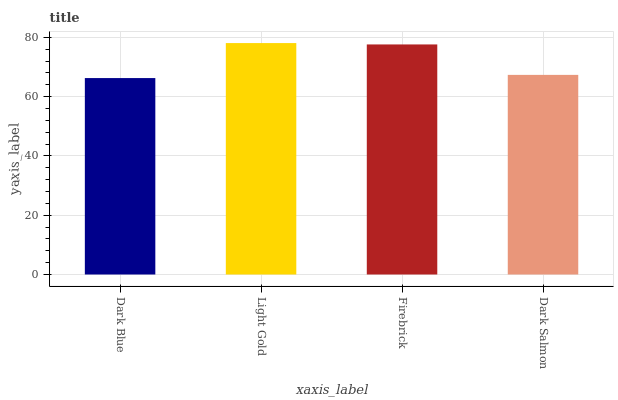Is Dark Blue the minimum?
Answer yes or no. Yes. Is Light Gold the maximum?
Answer yes or no. Yes. Is Firebrick the minimum?
Answer yes or no. No. Is Firebrick the maximum?
Answer yes or no. No. Is Light Gold greater than Firebrick?
Answer yes or no. Yes. Is Firebrick less than Light Gold?
Answer yes or no. Yes. Is Firebrick greater than Light Gold?
Answer yes or no. No. Is Light Gold less than Firebrick?
Answer yes or no. No. Is Firebrick the high median?
Answer yes or no. Yes. Is Dark Salmon the low median?
Answer yes or no. Yes. Is Dark Blue the high median?
Answer yes or no. No. Is Dark Blue the low median?
Answer yes or no. No. 